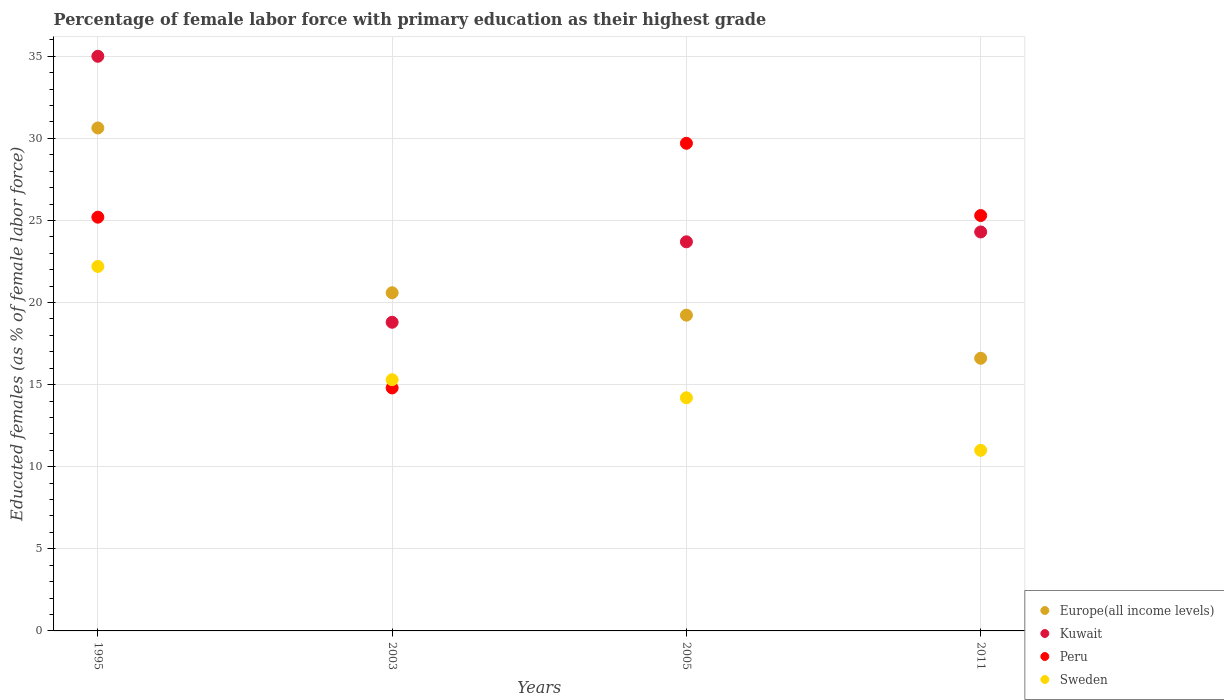What is the percentage of female labor force with primary education in Europe(all income levels) in 2005?
Keep it short and to the point. 19.23. Across all years, what is the maximum percentage of female labor force with primary education in Sweden?
Your answer should be compact. 22.2. Across all years, what is the minimum percentage of female labor force with primary education in Europe(all income levels)?
Your answer should be very brief. 16.61. In which year was the percentage of female labor force with primary education in Peru minimum?
Provide a succinct answer. 2003. What is the total percentage of female labor force with primary education in Peru in the graph?
Ensure brevity in your answer.  95. What is the difference between the percentage of female labor force with primary education in Europe(all income levels) in 1995 and that in 2011?
Ensure brevity in your answer.  14.03. What is the difference between the percentage of female labor force with primary education in Europe(all income levels) in 2011 and the percentage of female labor force with primary education in Kuwait in 2003?
Offer a very short reply. -2.19. What is the average percentage of female labor force with primary education in Peru per year?
Give a very brief answer. 23.75. In the year 2011, what is the difference between the percentage of female labor force with primary education in Peru and percentage of female labor force with primary education in Kuwait?
Keep it short and to the point. 1. In how many years, is the percentage of female labor force with primary education in Peru greater than 17 %?
Your answer should be very brief. 3. What is the ratio of the percentage of female labor force with primary education in Sweden in 2005 to that in 2011?
Make the answer very short. 1.29. What is the difference between the highest and the second highest percentage of female labor force with primary education in Peru?
Your answer should be very brief. 4.4. What is the difference between the highest and the lowest percentage of female labor force with primary education in Peru?
Ensure brevity in your answer.  14.9. In how many years, is the percentage of female labor force with primary education in Europe(all income levels) greater than the average percentage of female labor force with primary education in Europe(all income levels) taken over all years?
Provide a short and direct response. 1. Is the sum of the percentage of female labor force with primary education in Kuwait in 1995 and 2003 greater than the maximum percentage of female labor force with primary education in Sweden across all years?
Offer a terse response. Yes. Is it the case that in every year, the sum of the percentage of female labor force with primary education in Peru and percentage of female labor force with primary education in Kuwait  is greater than the sum of percentage of female labor force with primary education in Sweden and percentage of female labor force with primary education in Europe(all income levels)?
Give a very brief answer. No. Is it the case that in every year, the sum of the percentage of female labor force with primary education in Kuwait and percentage of female labor force with primary education in Europe(all income levels)  is greater than the percentage of female labor force with primary education in Sweden?
Your response must be concise. Yes. Is the percentage of female labor force with primary education in Sweden strictly greater than the percentage of female labor force with primary education in Peru over the years?
Offer a very short reply. No. What is the difference between two consecutive major ticks on the Y-axis?
Ensure brevity in your answer.  5. Are the values on the major ticks of Y-axis written in scientific E-notation?
Provide a succinct answer. No. How are the legend labels stacked?
Ensure brevity in your answer.  Vertical. What is the title of the graph?
Offer a terse response. Percentage of female labor force with primary education as their highest grade. Does "Faeroe Islands" appear as one of the legend labels in the graph?
Keep it short and to the point. No. What is the label or title of the X-axis?
Provide a short and direct response. Years. What is the label or title of the Y-axis?
Your answer should be compact. Educated females (as % of female labor force). What is the Educated females (as % of female labor force) of Europe(all income levels) in 1995?
Give a very brief answer. 30.63. What is the Educated females (as % of female labor force) in Peru in 1995?
Your answer should be compact. 25.2. What is the Educated females (as % of female labor force) of Sweden in 1995?
Your answer should be compact. 22.2. What is the Educated females (as % of female labor force) in Europe(all income levels) in 2003?
Your answer should be very brief. 20.6. What is the Educated females (as % of female labor force) in Kuwait in 2003?
Your answer should be compact. 18.8. What is the Educated females (as % of female labor force) of Peru in 2003?
Ensure brevity in your answer.  14.8. What is the Educated females (as % of female labor force) in Sweden in 2003?
Make the answer very short. 15.3. What is the Educated females (as % of female labor force) in Europe(all income levels) in 2005?
Offer a terse response. 19.23. What is the Educated females (as % of female labor force) of Kuwait in 2005?
Your answer should be very brief. 23.7. What is the Educated females (as % of female labor force) of Peru in 2005?
Make the answer very short. 29.7. What is the Educated females (as % of female labor force) in Sweden in 2005?
Your answer should be compact. 14.2. What is the Educated females (as % of female labor force) in Europe(all income levels) in 2011?
Ensure brevity in your answer.  16.61. What is the Educated females (as % of female labor force) in Kuwait in 2011?
Provide a succinct answer. 24.3. What is the Educated females (as % of female labor force) in Peru in 2011?
Make the answer very short. 25.3. Across all years, what is the maximum Educated females (as % of female labor force) in Europe(all income levels)?
Offer a very short reply. 30.63. Across all years, what is the maximum Educated females (as % of female labor force) of Kuwait?
Ensure brevity in your answer.  35. Across all years, what is the maximum Educated females (as % of female labor force) of Peru?
Your response must be concise. 29.7. Across all years, what is the maximum Educated females (as % of female labor force) in Sweden?
Ensure brevity in your answer.  22.2. Across all years, what is the minimum Educated females (as % of female labor force) of Europe(all income levels)?
Your answer should be very brief. 16.61. Across all years, what is the minimum Educated females (as % of female labor force) in Kuwait?
Offer a terse response. 18.8. Across all years, what is the minimum Educated females (as % of female labor force) in Peru?
Offer a terse response. 14.8. What is the total Educated females (as % of female labor force) in Europe(all income levels) in the graph?
Make the answer very short. 87.07. What is the total Educated females (as % of female labor force) of Kuwait in the graph?
Offer a terse response. 101.8. What is the total Educated females (as % of female labor force) in Sweden in the graph?
Your answer should be compact. 62.7. What is the difference between the Educated females (as % of female labor force) of Europe(all income levels) in 1995 and that in 2003?
Your answer should be very brief. 10.04. What is the difference between the Educated females (as % of female labor force) of Kuwait in 1995 and that in 2003?
Give a very brief answer. 16.2. What is the difference between the Educated females (as % of female labor force) of Sweden in 1995 and that in 2003?
Make the answer very short. 6.9. What is the difference between the Educated females (as % of female labor force) in Europe(all income levels) in 1995 and that in 2005?
Keep it short and to the point. 11.4. What is the difference between the Educated females (as % of female labor force) of Peru in 1995 and that in 2005?
Your response must be concise. -4.5. What is the difference between the Educated females (as % of female labor force) of Sweden in 1995 and that in 2005?
Your response must be concise. 8. What is the difference between the Educated females (as % of female labor force) in Europe(all income levels) in 1995 and that in 2011?
Your answer should be very brief. 14.03. What is the difference between the Educated females (as % of female labor force) in Peru in 1995 and that in 2011?
Provide a succinct answer. -0.1. What is the difference between the Educated females (as % of female labor force) in Europe(all income levels) in 2003 and that in 2005?
Keep it short and to the point. 1.37. What is the difference between the Educated females (as % of female labor force) in Peru in 2003 and that in 2005?
Your answer should be compact. -14.9. What is the difference between the Educated females (as % of female labor force) in Europe(all income levels) in 2003 and that in 2011?
Offer a very short reply. 3.99. What is the difference between the Educated females (as % of female labor force) of Europe(all income levels) in 2005 and that in 2011?
Ensure brevity in your answer.  2.63. What is the difference between the Educated females (as % of female labor force) of Kuwait in 2005 and that in 2011?
Offer a terse response. -0.6. What is the difference between the Educated females (as % of female labor force) in Europe(all income levels) in 1995 and the Educated females (as % of female labor force) in Kuwait in 2003?
Keep it short and to the point. 11.83. What is the difference between the Educated females (as % of female labor force) in Europe(all income levels) in 1995 and the Educated females (as % of female labor force) in Peru in 2003?
Your answer should be very brief. 15.83. What is the difference between the Educated females (as % of female labor force) in Europe(all income levels) in 1995 and the Educated females (as % of female labor force) in Sweden in 2003?
Your answer should be compact. 15.33. What is the difference between the Educated females (as % of female labor force) of Kuwait in 1995 and the Educated females (as % of female labor force) of Peru in 2003?
Provide a short and direct response. 20.2. What is the difference between the Educated females (as % of female labor force) of Kuwait in 1995 and the Educated females (as % of female labor force) of Sweden in 2003?
Your response must be concise. 19.7. What is the difference between the Educated females (as % of female labor force) of Europe(all income levels) in 1995 and the Educated females (as % of female labor force) of Kuwait in 2005?
Your answer should be very brief. 6.93. What is the difference between the Educated females (as % of female labor force) in Europe(all income levels) in 1995 and the Educated females (as % of female labor force) in Peru in 2005?
Keep it short and to the point. 0.93. What is the difference between the Educated females (as % of female labor force) of Europe(all income levels) in 1995 and the Educated females (as % of female labor force) of Sweden in 2005?
Offer a very short reply. 16.43. What is the difference between the Educated females (as % of female labor force) in Kuwait in 1995 and the Educated females (as % of female labor force) in Sweden in 2005?
Offer a terse response. 20.8. What is the difference between the Educated females (as % of female labor force) of Europe(all income levels) in 1995 and the Educated females (as % of female labor force) of Kuwait in 2011?
Your answer should be compact. 6.33. What is the difference between the Educated females (as % of female labor force) in Europe(all income levels) in 1995 and the Educated females (as % of female labor force) in Peru in 2011?
Ensure brevity in your answer.  5.33. What is the difference between the Educated females (as % of female labor force) in Europe(all income levels) in 1995 and the Educated females (as % of female labor force) in Sweden in 2011?
Your answer should be compact. 19.63. What is the difference between the Educated females (as % of female labor force) in Peru in 1995 and the Educated females (as % of female labor force) in Sweden in 2011?
Provide a short and direct response. 14.2. What is the difference between the Educated females (as % of female labor force) in Europe(all income levels) in 2003 and the Educated females (as % of female labor force) in Kuwait in 2005?
Provide a succinct answer. -3.1. What is the difference between the Educated females (as % of female labor force) in Europe(all income levels) in 2003 and the Educated females (as % of female labor force) in Peru in 2005?
Provide a short and direct response. -9.1. What is the difference between the Educated females (as % of female labor force) in Europe(all income levels) in 2003 and the Educated females (as % of female labor force) in Sweden in 2005?
Offer a very short reply. 6.4. What is the difference between the Educated females (as % of female labor force) in Kuwait in 2003 and the Educated females (as % of female labor force) in Peru in 2005?
Ensure brevity in your answer.  -10.9. What is the difference between the Educated females (as % of female labor force) in Kuwait in 2003 and the Educated females (as % of female labor force) in Sweden in 2005?
Your answer should be very brief. 4.6. What is the difference between the Educated females (as % of female labor force) in Peru in 2003 and the Educated females (as % of female labor force) in Sweden in 2005?
Give a very brief answer. 0.6. What is the difference between the Educated females (as % of female labor force) in Europe(all income levels) in 2003 and the Educated females (as % of female labor force) in Kuwait in 2011?
Keep it short and to the point. -3.7. What is the difference between the Educated females (as % of female labor force) of Europe(all income levels) in 2003 and the Educated females (as % of female labor force) of Peru in 2011?
Keep it short and to the point. -4.7. What is the difference between the Educated females (as % of female labor force) in Europe(all income levels) in 2003 and the Educated females (as % of female labor force) in Sweden in 2011?
Your answer should be compact. 9.6. What is the difference between the Educated females (as % of female labor force) in Peru in 2003 and the Educated females (as % of female labor force) in Sweden in 2011?
Provide a short and direct response. 3.8. What is the difference between the Educated females (as % of female labor force) of Europe(all income levels) in 2005 and the Educated females (as % of female labor force) of Kuwait in 2011?
Keep it short and to the point. -5.07. What is the difference between the Educated females (as % of female labor force) in Europe(all income levels) in 2005 and the Educated females (as % of female labor force) in Peru in 2011?
Make the answer very short. -6.07. What is the difference between the Educated females (as % of female labor force) in Europe(all income levels) in 2005 and the Educated females (as % of female labor force) in Sweden in 2011?
Offer a terse response. 8.23. What is the difference between the Educated females (as % of female labor force) of Peru in 2005 and the Educated females (as % of female labor force) of Sweden in 2011?
Ensure brevity in your answer.  18.7. What is the average Educated females (as % of female labor force) of Europe(all income levels) per year?
Provide a succinct answer. 21.77. What is the average Educated females (as % of female labor force) in Kuwait per year?
Your answer should be compact. 25.45. What is the average Educated females (as % of female labor force) in Peru per year?
Provide a short and direct response. 23.75. What is the average Educated females (as % of female labor force) of Sweden per year?
Give a very brief answer. 15.68. In the year 1995, what is the difference between the Educated females (as % of female labor force) in Europe(all income levels) and Educated females (as % of female labor force) in Kuwait?
Ensure brevity in your answer.  -4.37. In the year 1995, what is the difference between the Educated females (as % of female labor force) of Europe(all income levels) and Educated females (as % of female labor force) of Peru?
Your answer should be very brief. 5.43. In the year 1995, what is the difference between the Educated females (as % of female labor force) in Europe(all income levels) and Educated females (as % of female labor force) in Sweden?
Provide a short and direct response. 8.43. In the year 1995, what is the difference between the Educated females (as % of female labor force) of Kuwait and Educated females (as % of female labor force) of Peru?
Provide a succinct answer. 9.8. In the year 1995, what is the difference between the Educated females (as % of female labor force) of Kuwait and Educated females (as % of female labor force) of Sweden?
Give a very brief answer. 12.8. In the year 1995, what is the difference between the Educated females (as % of female labor force) of Peru and Educated females (as % of female labor force) of Sweden?
Your answer should be very brief. 3. In the year 2003, what is the difference between the Educated females (as % of female labor force) in Europe(all income levels) and Educated females (as % of female labor force) in Kuwait?
Give a very brief answer. 1.8. In the year 2003, what is the difference between the Educated females (as % of female labor force) in Europe(all income levels) and Educated females (as % of female labor force) in Peru?
Make the answer very short. 5.8. In the year 2003, what is the difference between the Educated females (as % of female labor force) in Europe(all income levels) and Educated females (as % of female labor force) in Sweden?
Your response must be concise. 5.3. In the year 2003, what is the difference between the Educated females (as % of female labor force) in Peru and Educated females (as % of female labor force) in Sweden?
Provide a succinct answer. -0.5. In the year 2005, what is the difference between the Educated females (as % of female labor force) in Europe(all income levels) and Educated females (as % of female labor force) in Kuwait?
Provide a short and direct response. -4.47. In the year 2005, what is the difference between the Educated females (as % of female labor force) of Europe(all income levels) and Educated females (as % of female labor force) of Peru?
Give a very brief answer. -10.47. In the year 2005, what is the difference between the Educated females (as % of female labor force) in Europe(all income levels) and Educated females (as % of female labor force) in Sweden?
Make the answer very short. 5.03. In the year 2005, what is the difference between the Educated females (as % of female labor force) in Kuwait and Educated females (as % of female labor force) in Peru?
Provide a succinct answer. -6. In the year 2005, what is the difference between the Educated females (as % of female labor force) in Kuwait and Educated females (as % of female labor force) in Sweden?
Offer a terse response. 9.5. In the year 2005, what is the difference between the Educated females (as % of female labor force) in Peru and Educated females (as % of female labor force) in Sweden?
Your answer should be very brief. 15.5. In the year 2011, what is the difference between the Educated females (as % of female labor force) of Europe(all income levels) and Educated females (as % of female labor force) of Kuwait?
Your answer should be very brief. -7.69. In the year 2011, what is the difference between the Educated females (as % of female labor force) of Europe(all income levels) and Educated females (as % of female labor force) of Peru?
Give a very brief answer. -8.69. In the year 2011, what is the difference between the Educated females (as % of female labor force) in Europe(all income levels) and Educated females (as % of female labor force) in Sweden?
Offer a very short reply. 5.61. In the year 2011, what is the difference between the Educated females (as % of female labor force) in Kuwait and Educated females (as % of female labor force) in Peru?
Your answer should be very brief. -1. In the year 2011, what is the difference between the Educated females (as % of female labor force) in Kuwait and Educated females (as % of female labor force) in Sweden?
Offer a terse response. 13.3. What is the ratio of the Educated females (as % of female labor force) of Europe(all income levels) in 1995 to that in 2003?
Offer a terse response. 1.49. What is the ratio of the Educated females (as % of female labor force) of Kuwait in 1995 to that in 2003?
Provide a succinct answer. 1.86. What is the ratio of the Educated females (as % of female labor force) of Peru in 1995 to that in 2003?
Give a very brief answer. 1.7. What is the ratio of the Educated females (as % of female labor force) in Sweden in 1995 to that in 2003?
Your answer should be compact. 1.45. What is the ratio of the Educated females (as % of female labor force) in Europe(all income levels) in 1995 to that in 2005?
Your response must be concise. 1.59. What is the ratio of the Educated females (as % of female labor force) in Kuwait in 1995 to that in 2005?
Your response must be concise. 1.48. What is the ratio of the Educated females (as % of female labor force) of Peru in 1995 to that in 2005?
Keep it short and to the point. 0.85. What is the ratio of the Educated females (as % of female labor force) in Sweden in 1995 to that in 2005?
Your answer should be compact. 1.56. What is the ratio of the Educated females (as % of female labor force) of Europe(all income levels) in 1995 to that in 2011?
Keep it short and to the point. 1.84. What is the ratio of the Educated females (as % of female labor force) of Kuwait in 1995 to that in 2011?
Offer a very short reply. 1.44. What is the ratio of the Educated females (as % of female labor force) of Sweden in 1995 to that in 2011?
Your answer should be compact. 2.02. What is the ratio of the Educated females (as % of female labor force) of Europe(all income levels) in 2003 to that in 2005?
Provide a succinct answer. 1.07. What is the ratio of the Educated females (as % of female labor force) in Kuwait in 2003 to that in 2005?
Give a very brief answer. 0.79. What is the ratio of the Educated females (as % of female labor force) in Peru in 2003 to that in 2005?
Give a very brief answer. 0.5. What is the ratio of the Educated females (as % of female labor force) of Sweden in 2003 to that in 2005?
Make the answer very short. 1.08. What is the ratio of the Educated females (as % of female labor force) in Europe(all income levels) in 2003 to that in 2011?
Your answer should be very brief. 1.24. What is the ratio of the Educated females (as % of female labor force) of Kuwait in 2003 to that in 2011?
Provide a succinct answer. 0.77. What is the ratio of the Educated females (as % of female labor force) in Peru in 2003 to that in 2011?
Your answer should be compact. 0.58. What is the ratio of the Educated females (as % of female labor force) in Sweden in 2003 to that in 2011?
Keep it short and to the point. 1.39. What is the ratio of the Educated females (as % of female labor force) of Europe(all income levels) in 2005 to that in 2011?
Offer a terse response. 1.16. What is the ratio of the Educated females (as % of female labor force) in Kuwait in 2005 to that in 2011?
Provide a succinct answer. 0.98. What is the ratio of the Educated females (as % of female labor force) of Peru in 2005 to that in 2011?
Offer a terse response. 1.17. What is the ratio of the Educated females (as % of female labor force) of Sweden in 2005 to that in 2011?
Your answer should be compact. 1.29. What is the difference between the highest and the second highest Educated females (as % of female labor force) in Europe(all income levels)?
Provide a short and direct response. 10.04. What is the difference between the highest and the second highest Educated females (as % of female labor force) of Peru?
Provide a short and direct response. 4.4. What is the difference between the highest and the second highest Educated females (as % of female labor force) of Sweden?
Make the answer very short. 6.9. What is the difference between the highest and the lowest Educated females (as % of female labor force) of Europe(all income levels)?
Offer a very short reply. 14.03. What is the difference between the highest and the lowest Educated females (as % of female labor force) in Peru?
Provide a succinct answer. 14.9. What is the difference between the highest and the lowest Educated females (as % of female labor force) in Sweden?
Give a very brief answer. 11.2. 